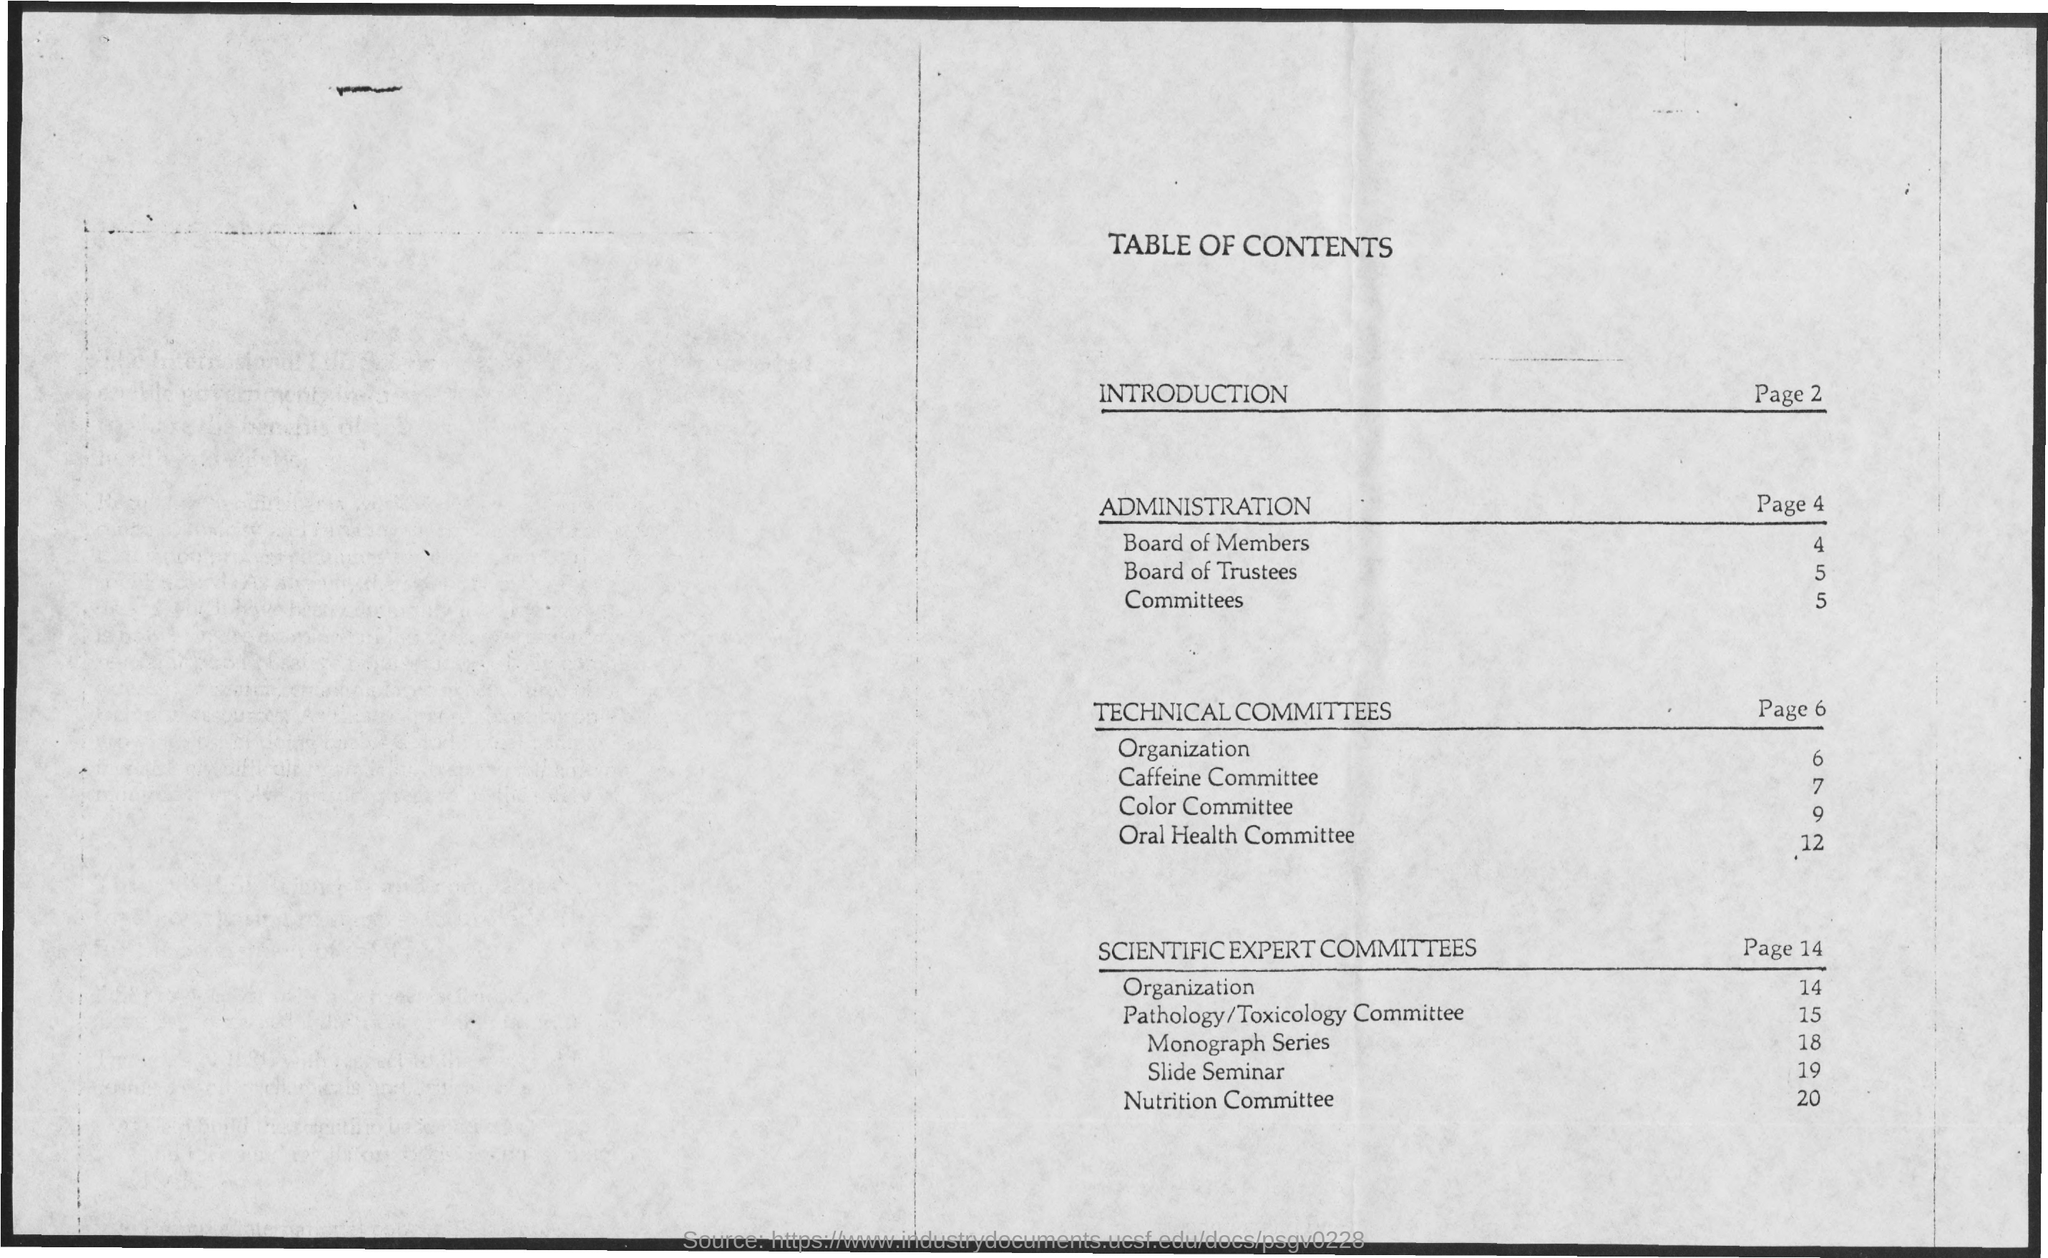Specify some key components in this picture. The topic "Slide Seminar" is discussed on page 19. The title of the document is 'Table of Contents'. The topic "Nutrition Committee" is discussed on page 20. The topic "Color Committee" is located on page 9. The topic "Board of Members" is located on page 4. 